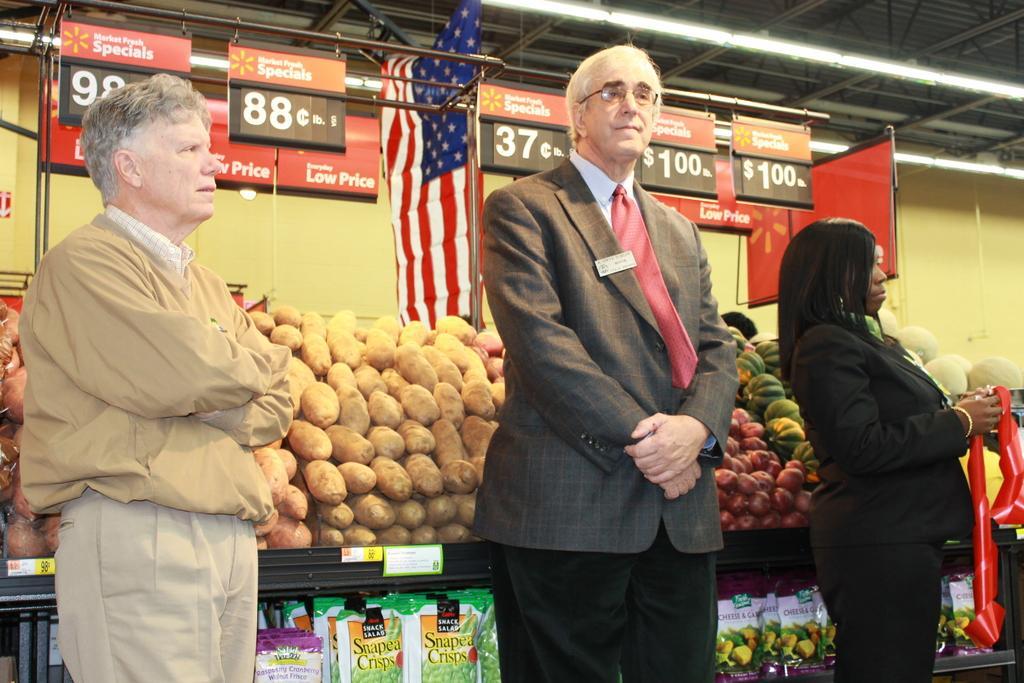In one or two sentences, can you explain what this image depicts? In this image I see 2 men and a woman who are standing and this woman is holding a red color thing in her hands. In the background I see the groceries on these racks and I see the tags over here and I see the boards on which there is something is written and I see the flag over here and I see the lights on the ceiling. 